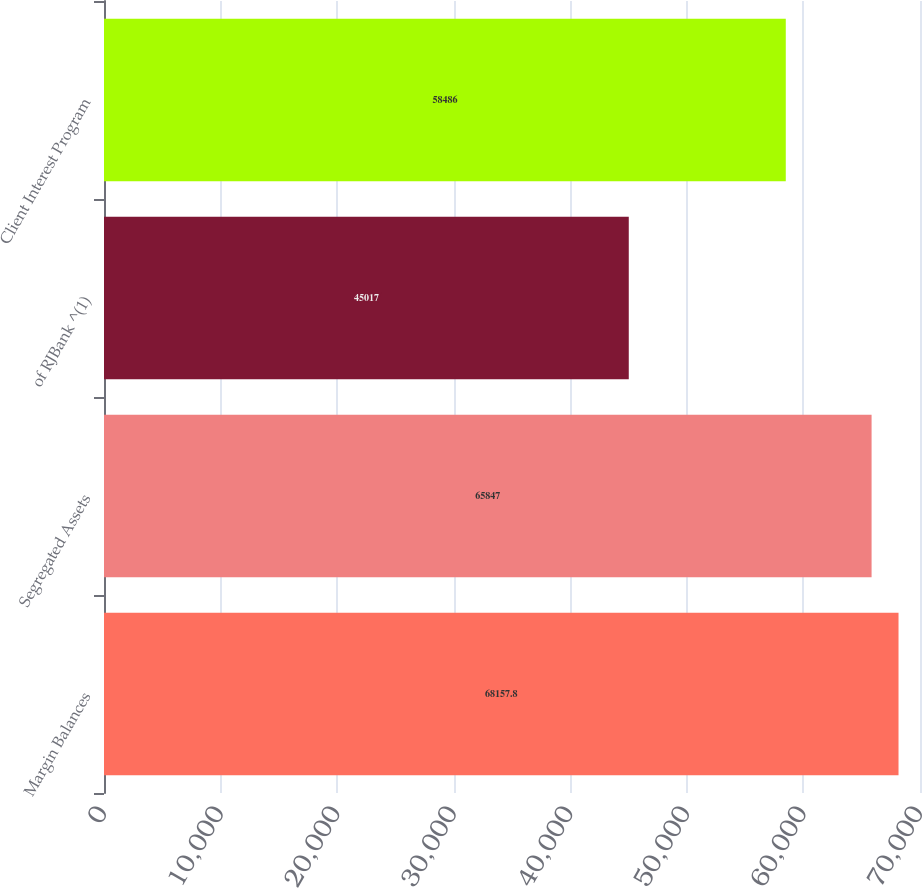<chart> <loc_0><loc_0><loc_500><loc_500><bar_chart><fcel>Margin Balances<fcel>Segregated Assets<fcel>of RJBank ^(1)<fcel>Client Interest Program<nl><fcel>68157.8<fcel>65847<fcel>45017<fcel>58486<nl></chart> 